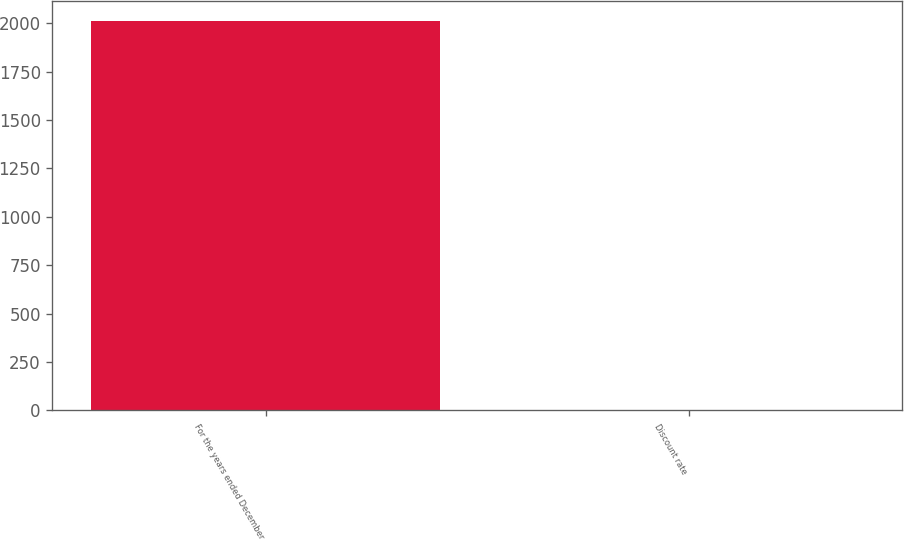Convert chart to OTSL. <chart><loc_0><loc_0><loc_500><loc_500><bar_chart><fcel>For the years ended December<fcel>Discount rate<nl><fcel>2014<fcel>4.5<nl></chart> 